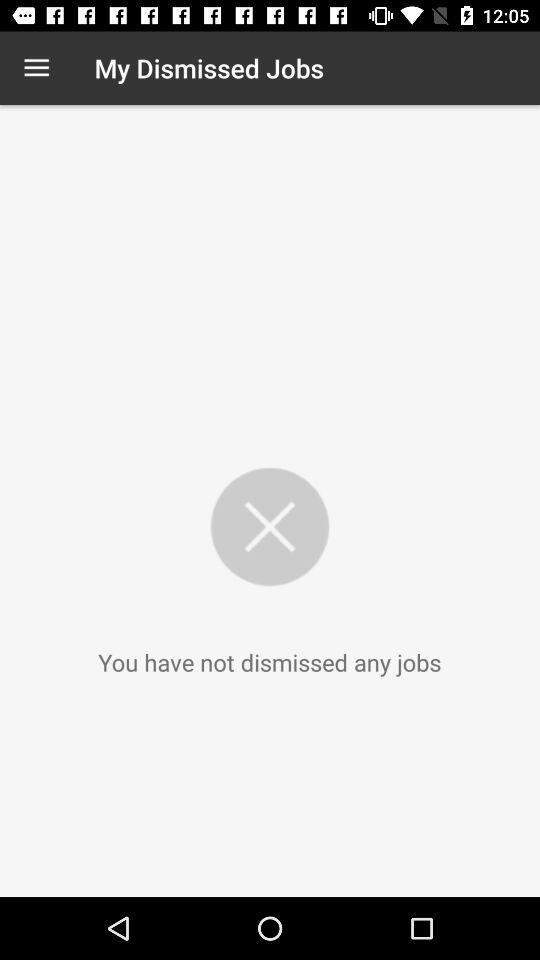How many dismissed jobs does the user have?
Answer the question using a single word or phrase. 0 